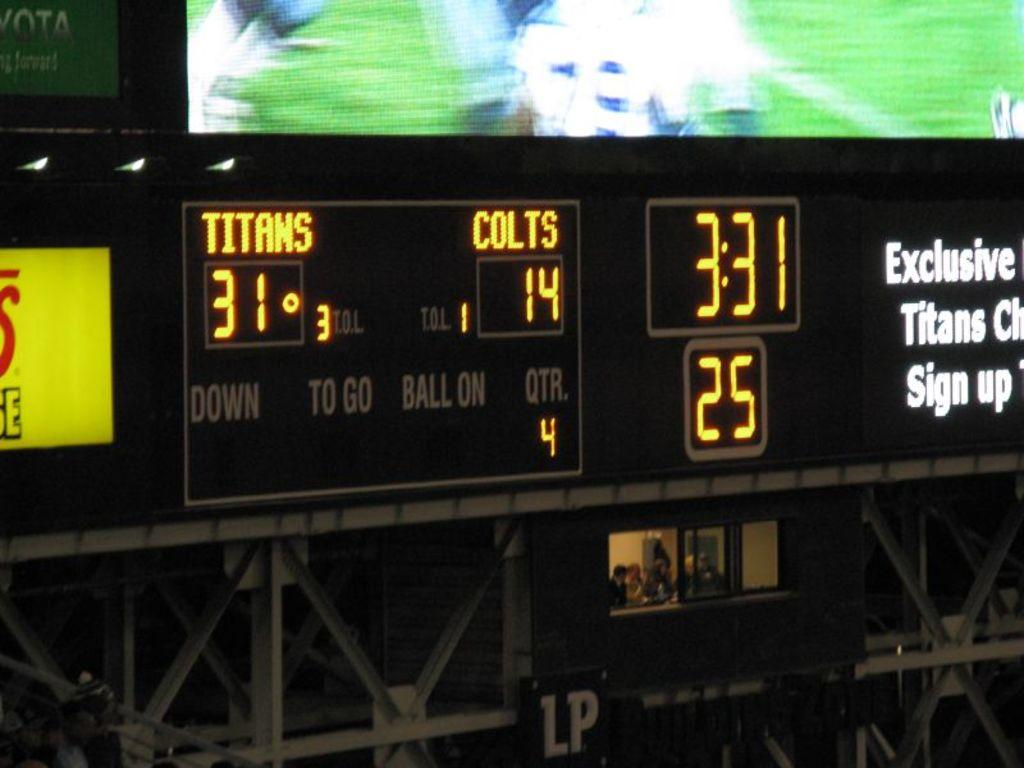<image>
Render a clear and concise summary of the photo. A scoreboard for a sports match shows that the Titans are leading the Colts 31 to 14. 